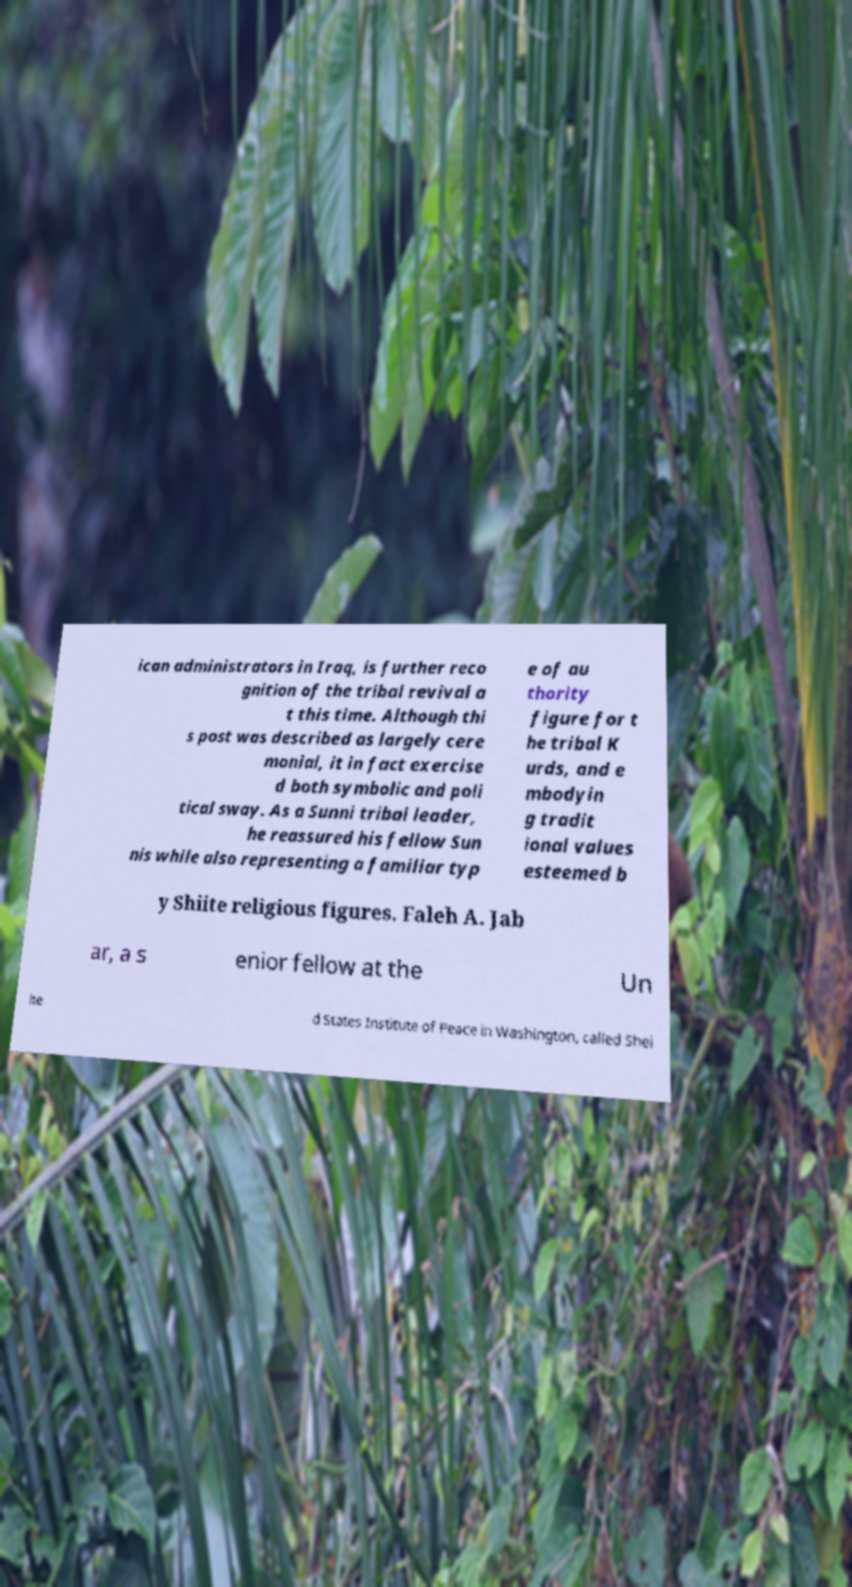Can you accurately transcribe the text from the provided image for me? ican administrators in Iraq, is further reco gnition of the tribal revival a t this time. Although thi s post was described as largely cere monial, it in fact exercise d both symbolic and poli tical sway. As a Sunni tribal leader, he reassured his fellow Sun nis while also representing a familiar typ e of au thority figure for t he tribal K urds, and e mbodyin g tradit ional values esteemed b y Shiite religious figures. Faleh A. Jab ar, a s enior fellow at the Un ite d States Institute of Peace in Washington, called Shei 